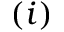<formula> <loc_0><loc_0><loc_500><loc_500>( i )</formula> 